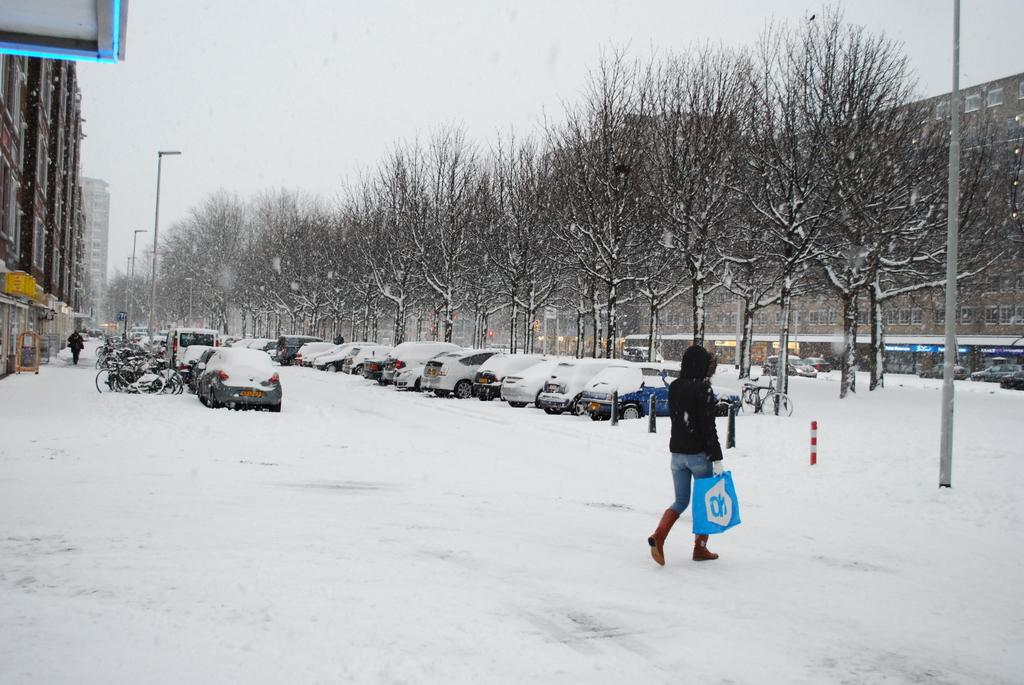What is the primary feature of the image's environment? There is snow in the image. How many people can be seen in the image? There are two persons standing in the image. What other objects are present in the image? There are vehicles, poles, lights, trees, buildings, and boards in the image. What can be seen in the background of the image? The sky is visible in the background of the image. What type of book is being read by the person standing on the left in the image? There is no book present in the image, and therefore no one is reading a book. Can you confirm the existence of yams in the image? There are no yams present in the image. 